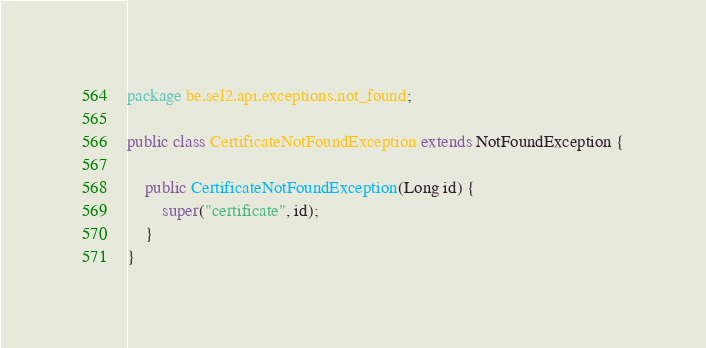<code> <loc_0><loc_0><loc_500><loc_500><_Java_>package be.sel2.api.exceptions.not_found;

public class CertificateNotFoundException extends NotFoundException {

    public CertificateNotFoundException(Long id) {
        super("certificate", id);
    }
}
</code> 